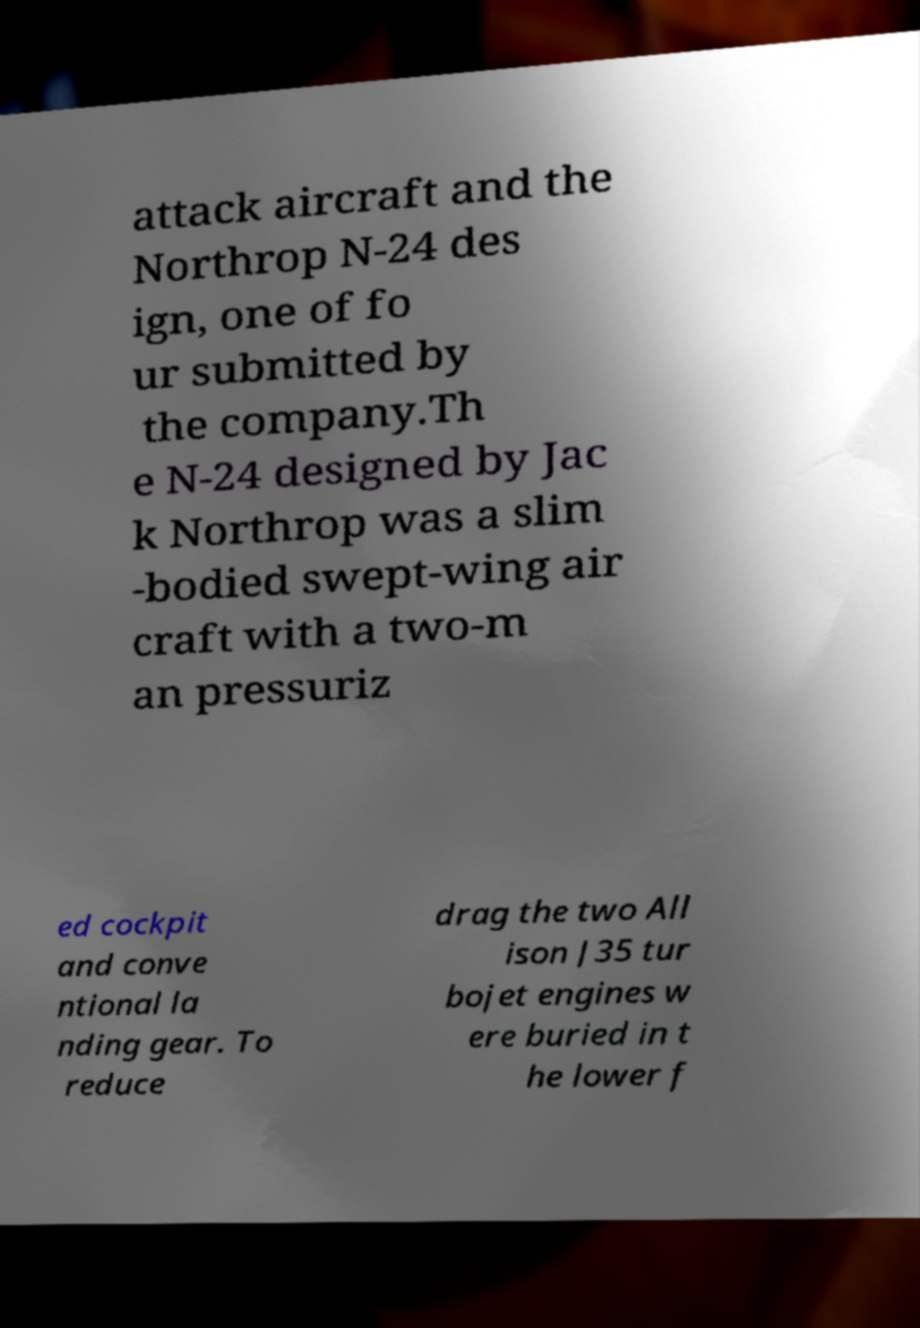Can you accurately transcribe the text from the provided image for me? attack aircraft and the Northrop N-24 des ign, one of fo ur submitted by the company.Th e N-24 designed by Jac k Northrop was a slim -bodied swept-wing air craft with a two-m an pressuriz ed cockpit and conve ntional la nding gear. To reduce drag the two All ison J35 tur bojet engines w ere buried in t he lower f 